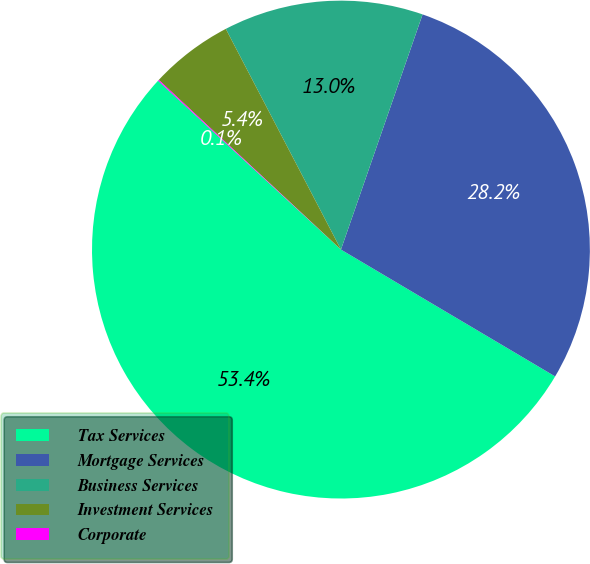Convert chart. <chart><loc_0><loc_0><loc_500><loc_500><pie_chart><fcel>Tax Services<fcel>Mortgage Services<fcel>Business Services<fcel>Investment Services<fcel>Corporate<nl><fcel>53.35%<fcel>28.19%<fcel>12.97%<fcel>5.41%<fcel>0.07%<nl></chart> 